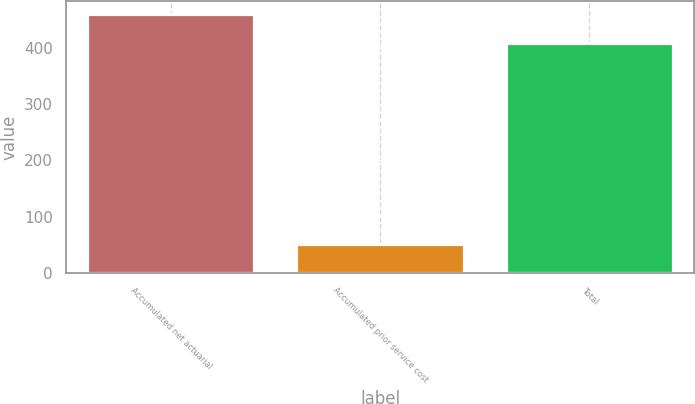Convert chart to OTSL. <chart><loc_0><loc_0><loc_500><loc_500><bar_chart><fcel>Accumulated net actuarial<fcel>Accumulated prior service cost<fcel>Total<nl><fcel>460<fcel>51<fcel>409<nl></chart> 